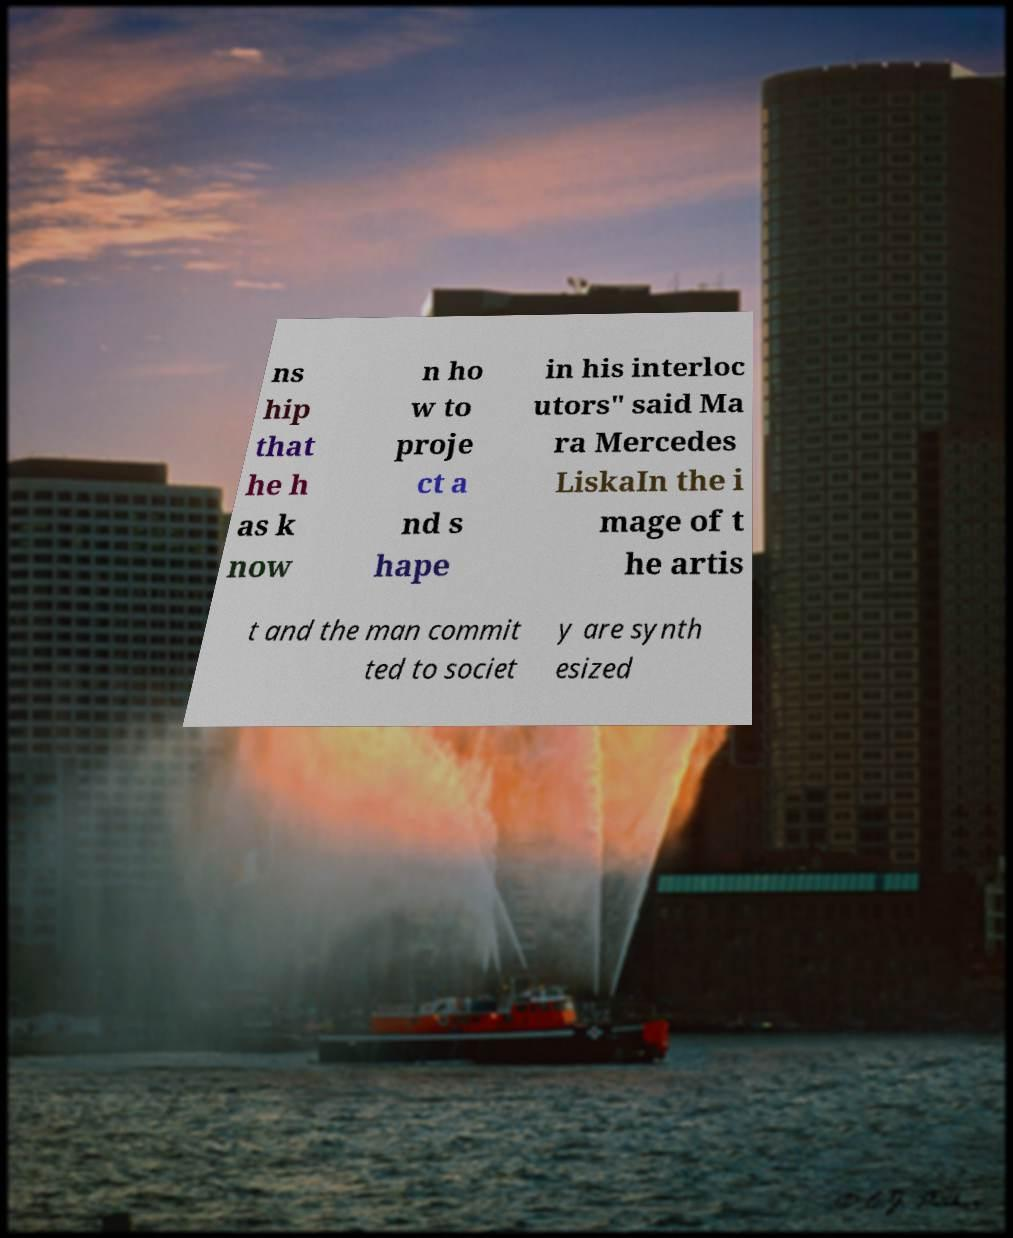There's text embedded in this image that I need extracted. Can you transcribe it verbatim? ns hip that he h as k now n ho w to proje ct a nd s hape in his interloc utors" said Ma ra Mercedes LiskaIn the i mage of t he artis t and the man commit ted to societ y are synth esized 